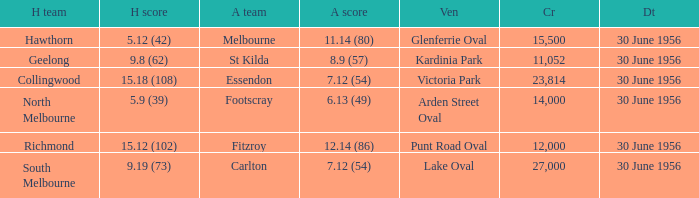What is the home team for punt road oval? Richmond. 